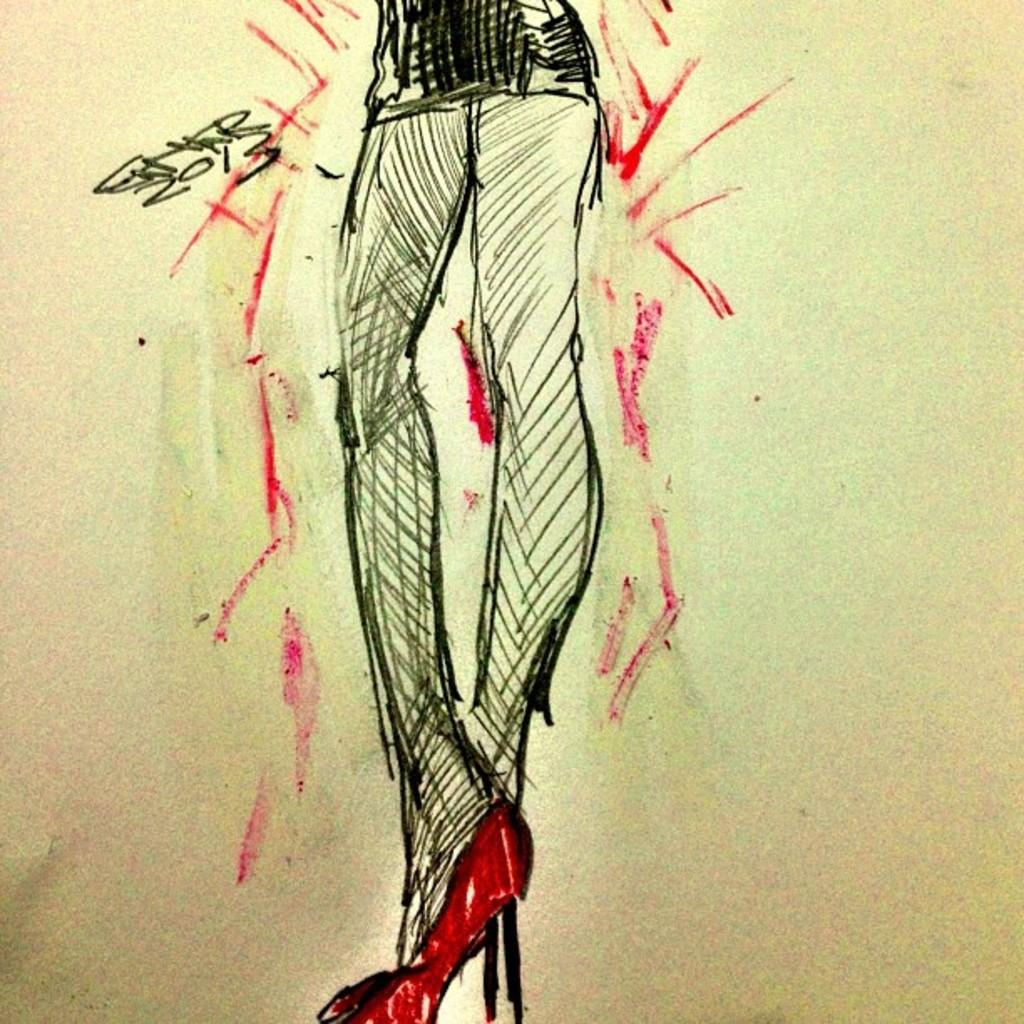What is depicted in the image? There is a sketch painting in the image. Where is the sketch painting located? The sketch painting is on a wall. What type of money is depicted in the sketch painting? There is no money depicted in the sketch painting; it is a painting and not a representation of currency. What type of iron material is used to create the sketch painting? There is no information about the materials used to create the sketch painting in the image. 